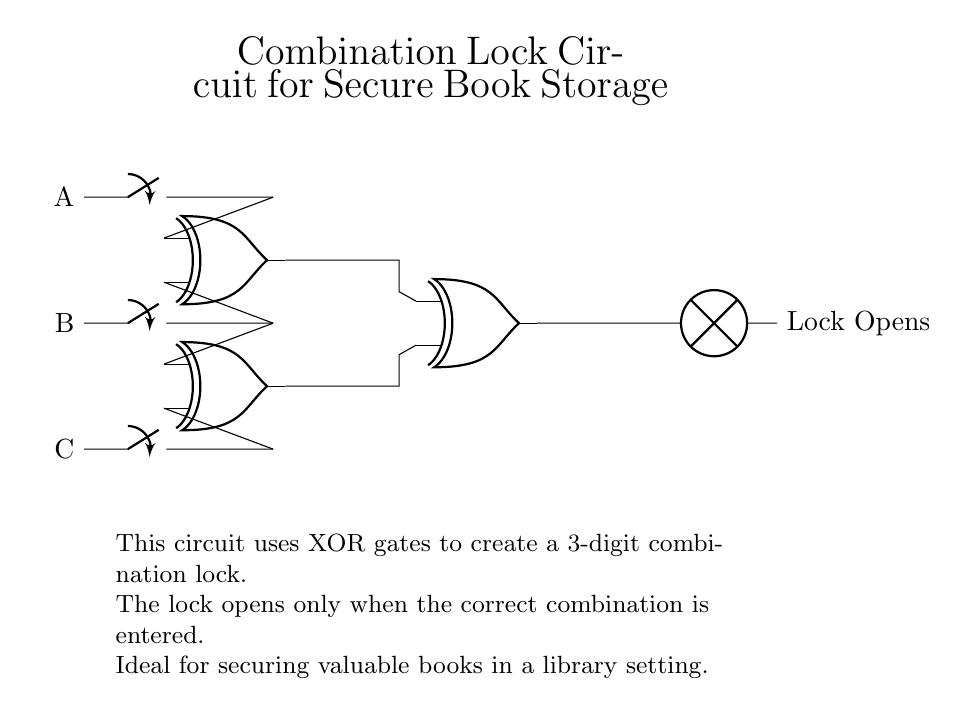What are the input components of the circuit? The circuit has three input components: A, B, and C, which are represented by the switches on the left side.
Answer: A, B, C How many XOR gates are used in this combination lock circuit? The diagram shows three XOR gates connected in series, which are used to process the inputs to determine the lock status.
Answer: Three What does the output of the circuit indicate? The output from the final XOR gate leads to a lamp that signifies the lock opens when the correct combination is inputted.
Answer: Lock Opens What is the purpose of using XOR gates in this circuit? XOR gates are used because they provide a true output (lock opens) only when an odd number of inputs are true, making them suitable for a secure combination lock mechanism.
Answer: Secure combination logic What is the significance of the correct combination for the lock to open? The lock opens only when the correct combination of inputs (A, B, C) is provided, highlighting the necessity of a specific input selection to activate the output.
Answer: Correct combination required How does the circuit ensure security for valuable books? The use of multiple inputs (three switches) and the XOR gates ensures that only a unique combination will unlock the mechanism, hence securing the valuable content.
Answer: Unique combination security 